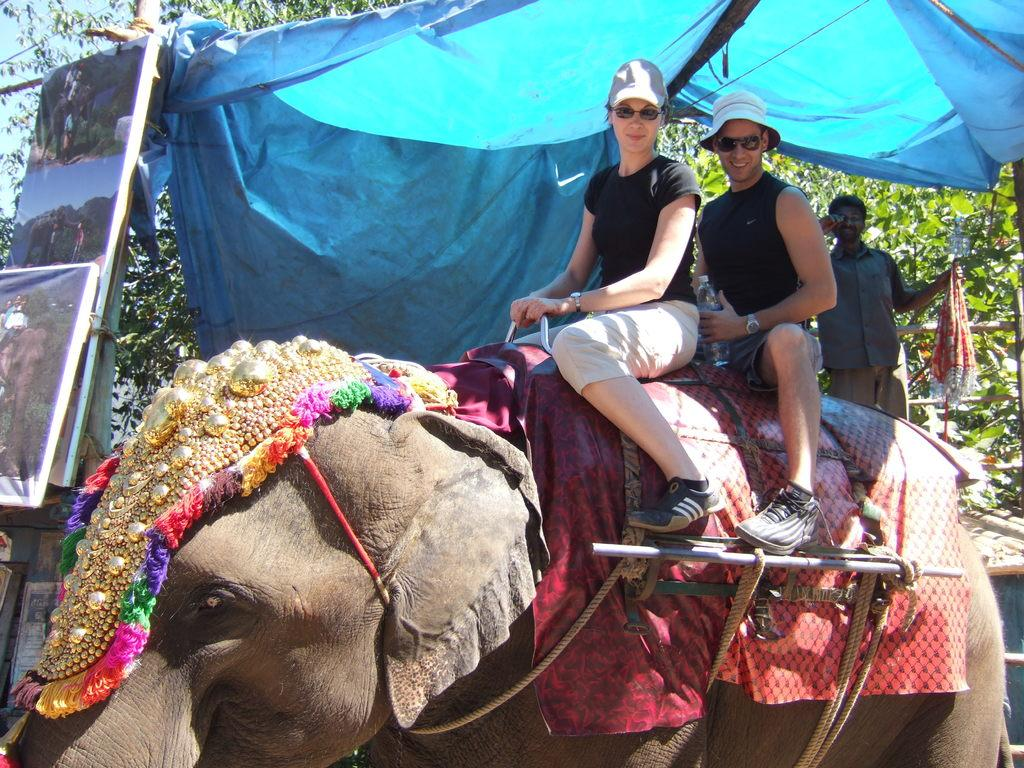What are the two persons on the elephant doing? The two persons are sitting on an elephant. What are the persons wearing on their heads? The persons are wearing caps. What type of eyewear are the persons wearing? The persons are wearing glasses. What can be seen in the background of the image? There is a person holding cloth, trees, a tent, and boards in the background. What type of toy is the elephant playing with in the image? There is no toy present in the image, and the elephant is not shown playing with anything. What kind of insurance policy does the person holding cloth have in the image? There is no information about insurance policies in the image; it only shows a person holding cloth in the background. 